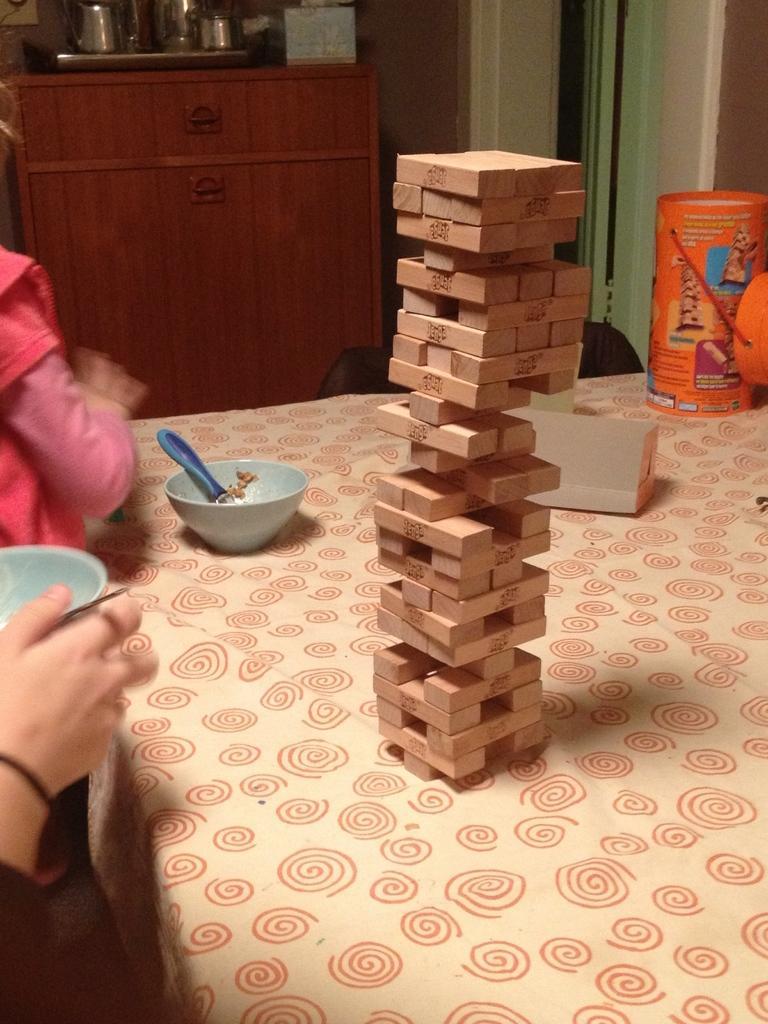Can you describe this image briefly? In the center of the image we can see jenga blocks placed on the table. On the table we can see bowl, spoon and objects. On the left side of the image we can see persons. In the background there is a cupboard,curtain, wall and some objects. 